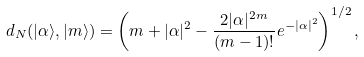Convert formula to latex. <formula><loc_0><loc_0><loc_500><loc_500>d _ { N } ( | \alpha \rangle , | m \rangle ) = \left ( m + | \alpha | ^ { 2 } - \frac { 2 | \alpha | ^ { 2 m } } { ( m - 1 ) ! } e ^ { - | \alpha | ^ { 2 } } \right ) ^ { 1 / 2 } ,</formula> 